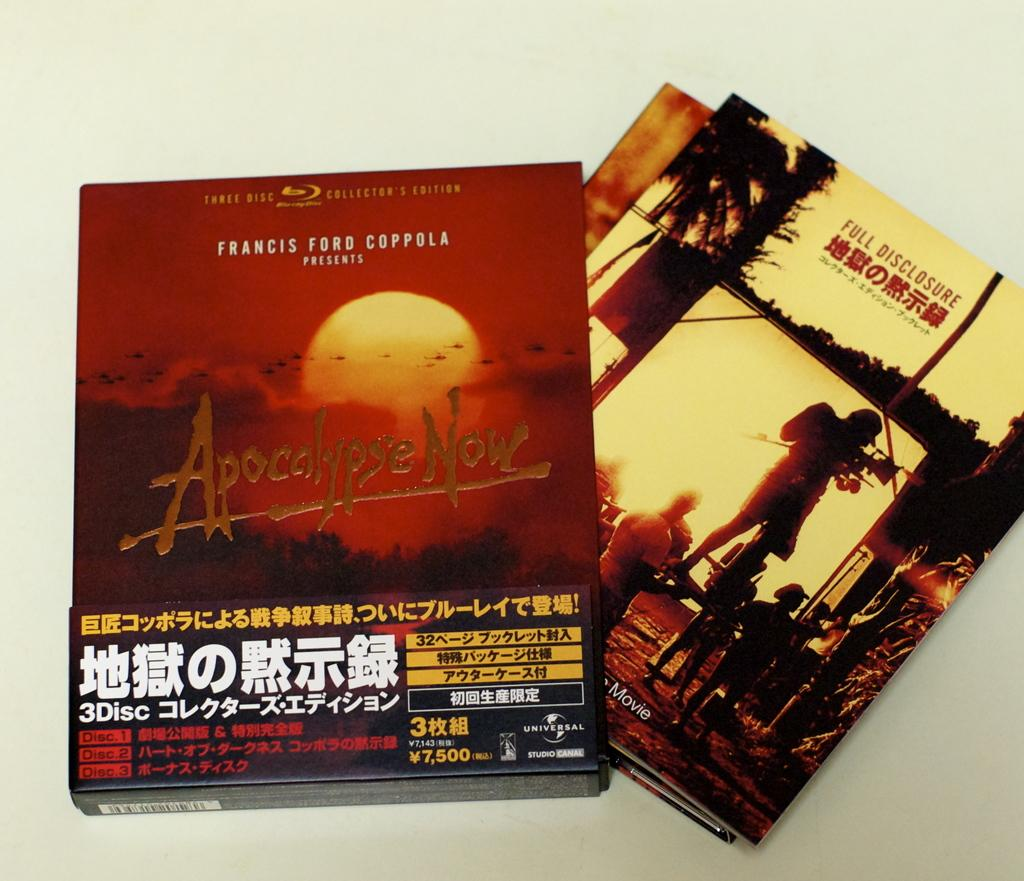What object can be seen in the image? There is a box in the image. What else is present on the table in the image? There are CD covers on the table in the image. What reason does the box have for needing to produce more CD covers? There is no indication in the image that the box needs to produce more CD covers or has any reason for doing so. 